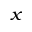<formula> <loc_0><loc_0><loc_500><loc_500>_ { x }</formula> 